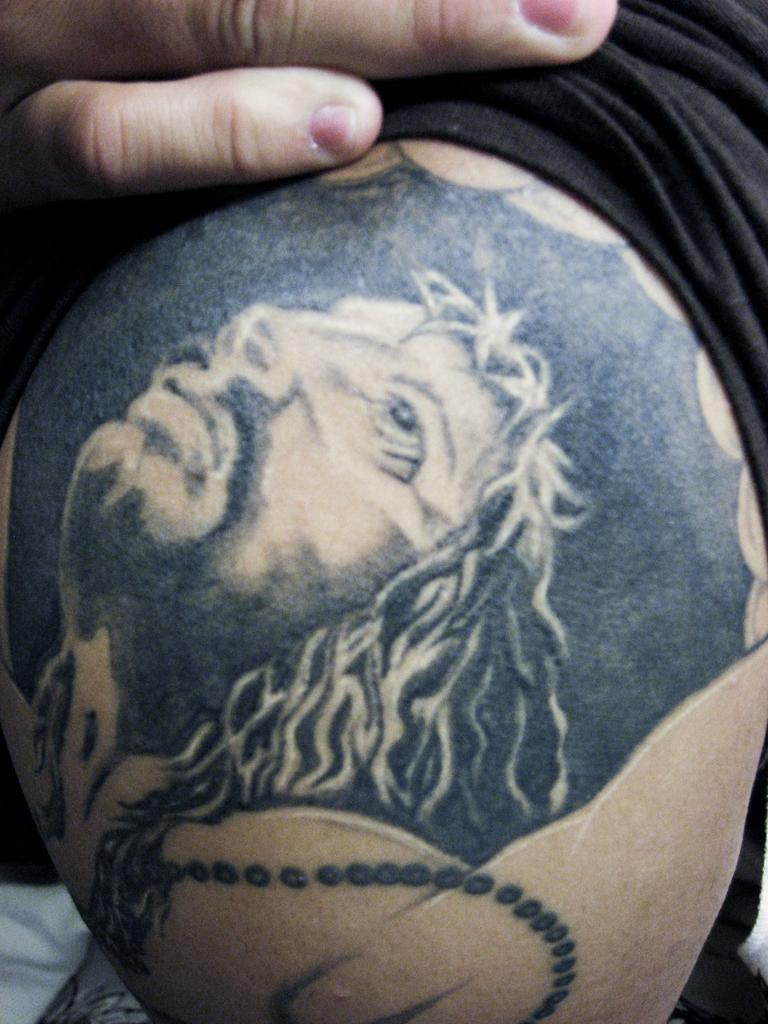What is present in the image? There is a man in the image. Can you describe any distinguishing features of the man? The man has a tattoo. What type of guide is the man holding in the image? There is no guide present in the image; it only features a man with a tattoo. 